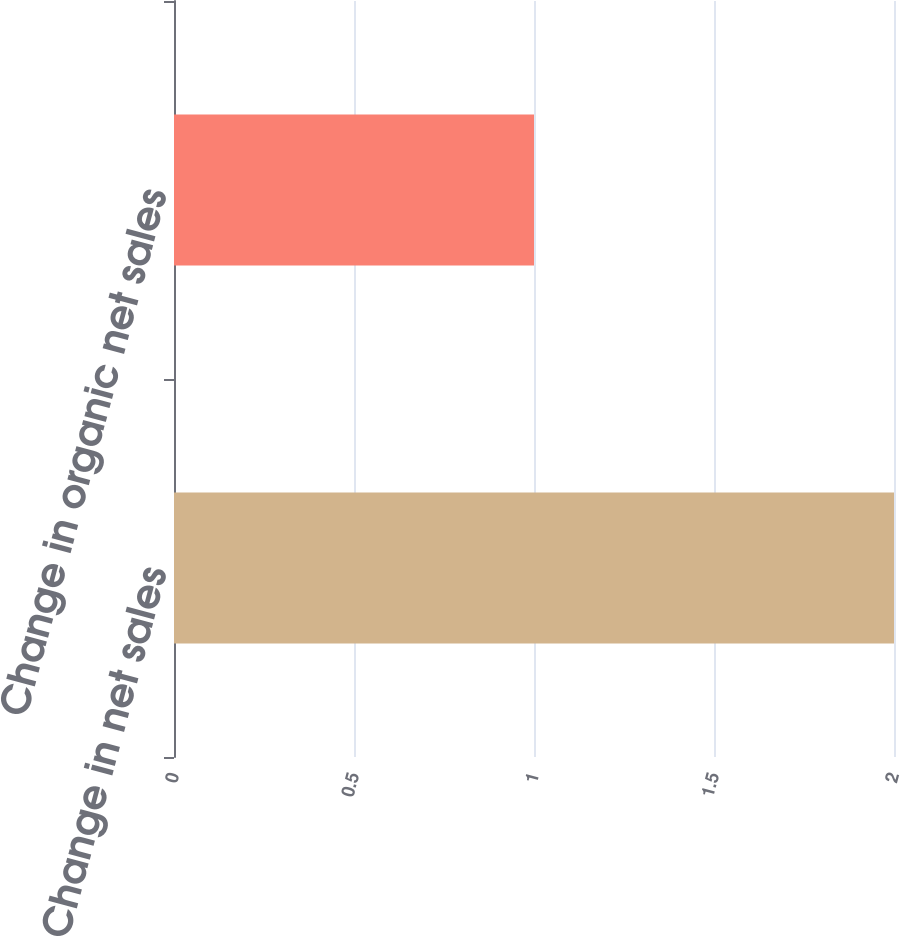Convert chart to OTSL. <chart><loc_0><loc_0><loc_500><loc_500><bar_chart><fcel>Change in net sales<fcel>Change in organic net sales<nl><fcel>2<fcel>1<nl></chart> 